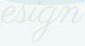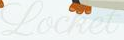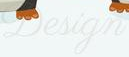What text is displayed in these images sequentially, separated by a semicolon? esign; Locket; Design 